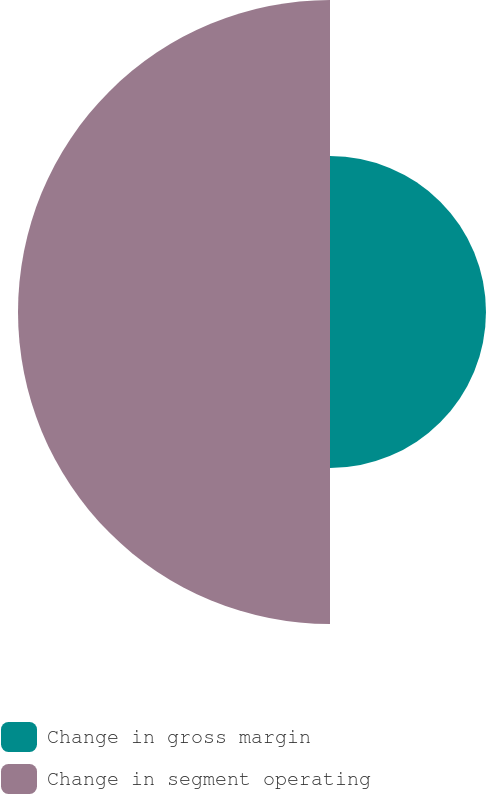Convert chart to OTSL. <chart><loc_0><loc_0><loc_500><loc_500><pie_chart><fcel>Change in gross margin<fcel>Change in segment operating<nl><fcel>33.33%<fcel>66.67%<nl></chart> 